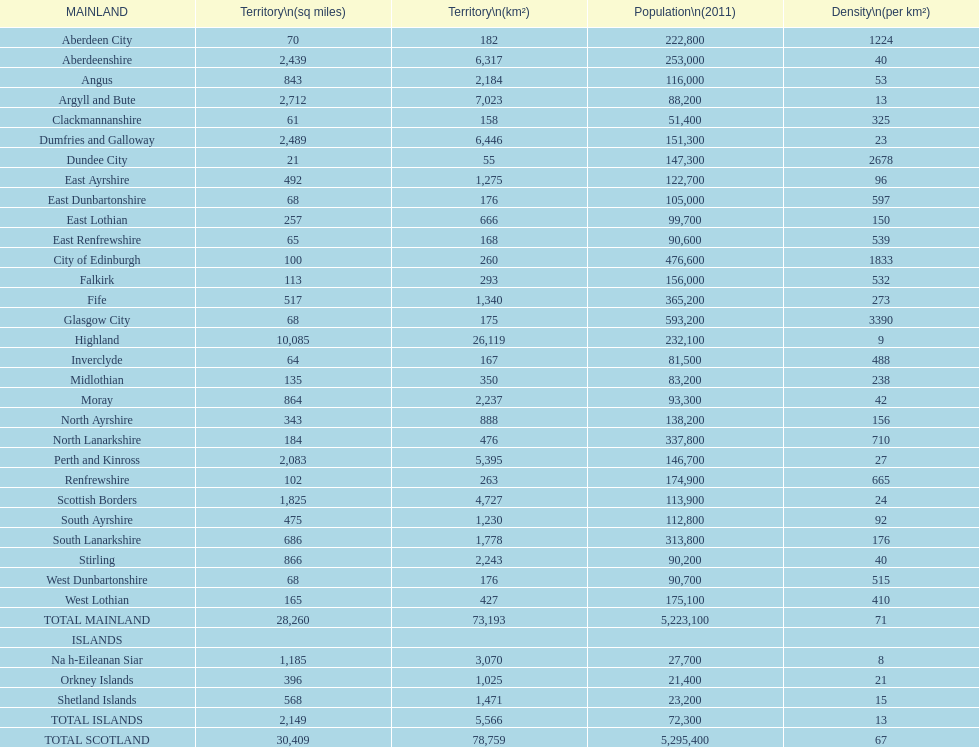On which mainland is the population the smallest? Clackmannanshire. 